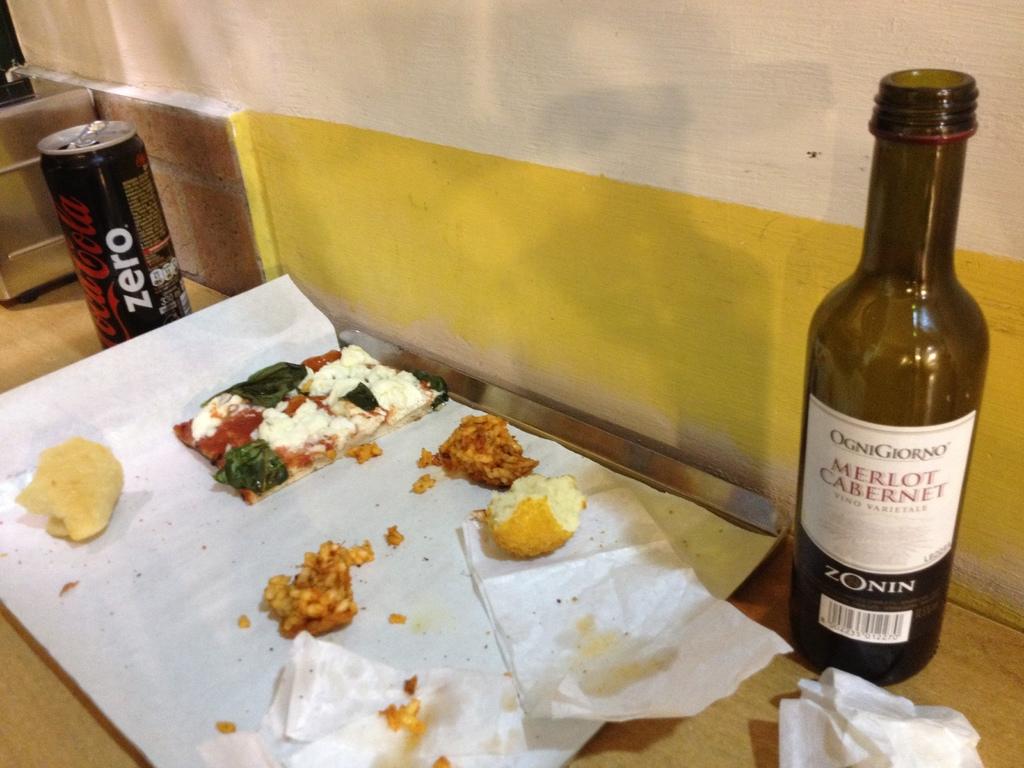What type of coke product is shown?
Your answer should be very brief. Coke zero. 